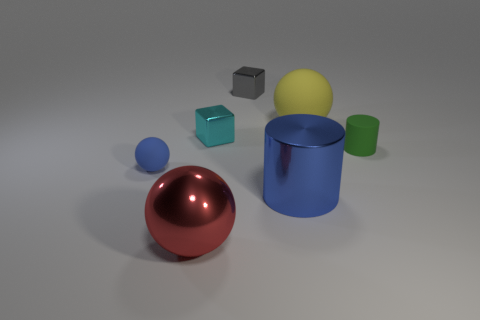How many other objects have the same shape as the gray thing?
Your answer should be very brief. 1. The small thing that is both in front of the cyan metal block and behind the tiny matte sphere is what color?
Your response must be concise. Green. What number of purple objects are there?
Provide a succinct answer. 0. Do the green rubber object and the gray metal block have the same size?
Keep it short and to the point. Yes. Are there any other big shiny cylinders that have the same color as the big cylinder?
Offer a very short reply. No. There is a small green thing that is in front of the yellow matte thing; is it the same shape as the red metallic thing?
Provide a succinct answer. No. How many cyan blocks are the same size as the blue rubber ball?
Give a very brief answer. 1. What number of large things are to the left of the large sphere that is behind the cyan object?
Ensure brevity in your answer.  2. Are the large ball in front of the green cylinder and the green thing made of the same material?
Offer a very short reply. No. Is the large sphere behind the big red object made of the same material as the small thing that is in front of the tiny matte cylinder?
Your answer should be very brief. Yes. 